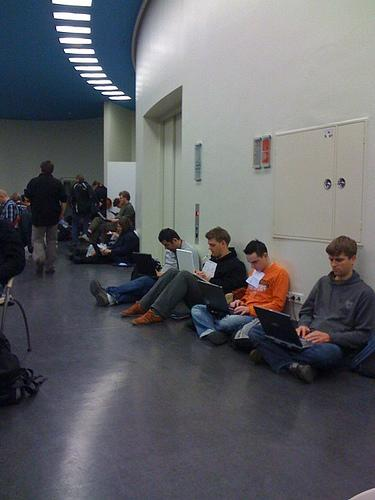What are the men against the wall working on?

Choices:
A) ipods
B) tablets
C) laptop
D) desktops laptop 